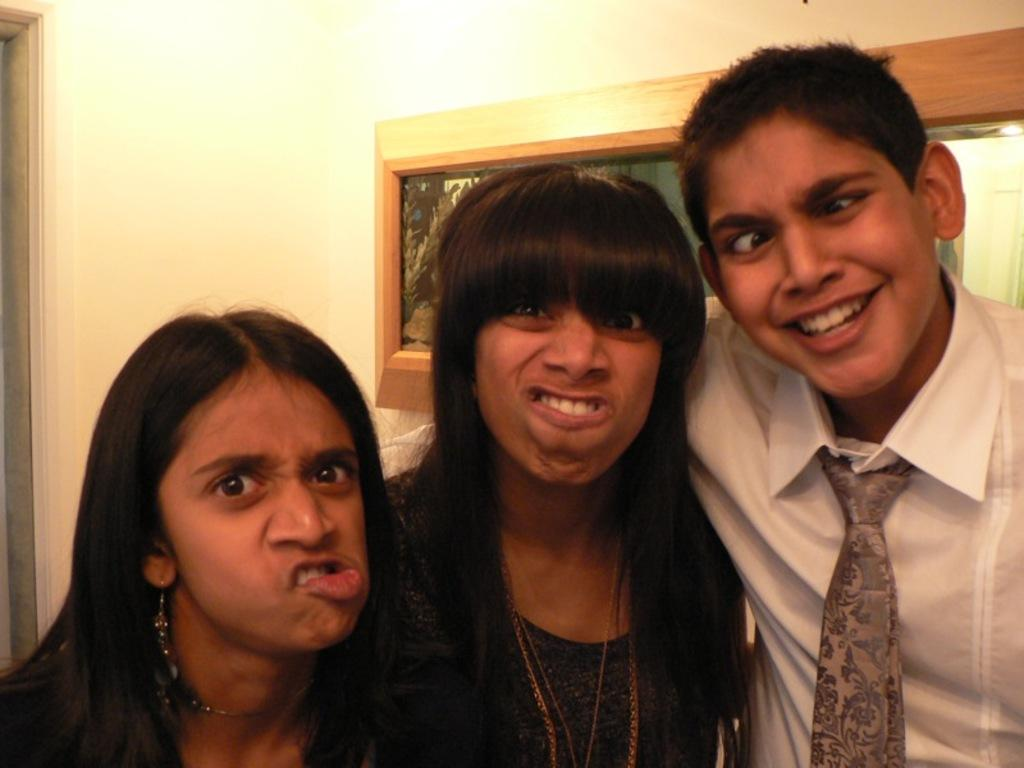How many people are in the image? There are three persons in the image. Can you describe the attire of one of the persons? One person is wearing a tie. What type of vegetation can be seen in the background? There are plants in a glass container in the background. What architectural feature is visible in the background? There is a door visible in the background. What type of nerve can be seen in the image? There is no nerve visible in the image. Can you describe the behavior of the rays in the image? There are no rays present in the image. 